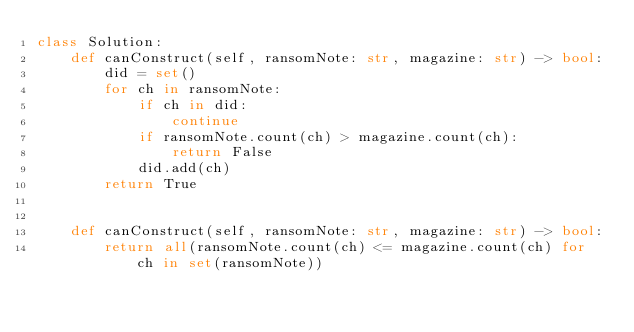Convert code to text. <code><loc_0><loc_0><loc_500><loc_500><_Python_>class Solution:
    def canConstruct(self, ransomNote: str, magazine: str) -> bool:
        did = set()
        for ch in ransomNote:
            if ch in did:
                continue
            if ransomNote.count(ch) > magazine.count(ch):
                return False
            did.add(ch)
        return True


    def canConstruct(self, ransomNote: str, magazine: str) -> bool:
        return all(ransomNote.count(ch) <= magazine.count(ch) for ch in set(ransomNote))
</code> 